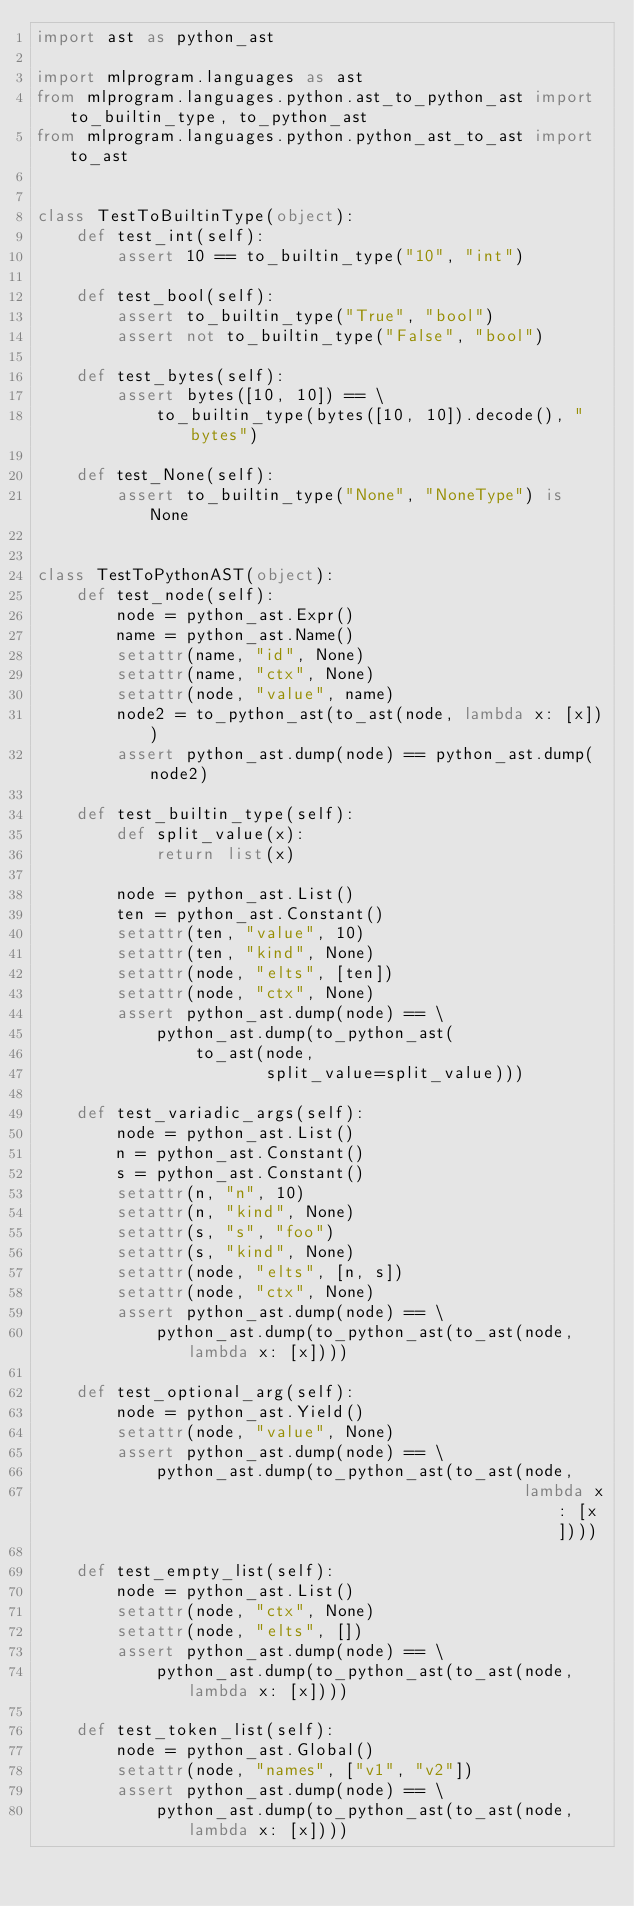Convert code to text. <code><loc_0><loc_0><loc_500><loc_500><_Python_>import ast as python_ast

import mlprogram.languages as ast
from mlprogram.languages.python.ast_to_python_ast import to_builtin_type, to_python_ast
from mlprogram.languages.python.python_ast_to_ast import to_ast


class TestToBuiltinType(object):
    def test_int(self):
        assert 10 == to_builtin_type("10", "int")

    def test_bool(self):
        assert to_builtin_type("True", "bool")
        assert not to_builtin_type("False", "bool")

    def test_bytes(self):
        assert bytes([10, 10]) == \
            to_builtin_type(bytes([10, 10]).decode(), "bytes")

    def test_None(self):
        assert to_builtin_type("None", "NoneType") is None


class TestToPythonAST(object):
    def test_node(self):
        node = python_ast.Expr()
        name = python_ast.Name()
        setattr(name, "id", None)
        setattr(name, "ctx", None)
        setattr(node, "value", name)
        node2 = to_python_ast(to_ast(node, lambda x: [x]))
        assert python_ast.dump(node) == python_ast.dump(node2)

    def test_builtin_type(self):
        def split_value(x):
            return list(x)

        node = python_ast.List()
        ten = python_ast.Constant()
        setattr(ten, "value", 10)
        setattr(ten, "kind", None)
        setattr(node, "elts", [ten])
        setattr(node, "ctx", None)
        assert python_ast.dump(node) == \
            python_ast.dump(to_python_ast(
                to_ast(node,
                       split_value=split_value)))

    def test_variadic_args(self):
        node = python_ast.List()
        n = python_ast.Constant()
        s = python_ast.Constant()
        setattr(n, "n", 10)
        setattr(n, "kind", None)
        setattr(s, "s", "foo")
        setattr(s, "kind", None)
        setattr(node, "elts", [n, s])
        setattr(node, "ctx", None)
        assert python_ast.dump(node) == \
            python_ast.dump(to_python_ast(to_ast(node, lambda x: [x])))

    def test_optional_arg(self):
        node = python_ast.Yield()
        setattr(node, "value", None)
        assert python_ast.dump(node) == \
            python_ast.dump(to_python_ast(to_ast(node,
                                                 lambda x: [x])))

    def test_empty_list(self):
        node = python_ast.List()
        setattr(node, "ctx", None)
        setattr(node, "elts", [])
        assert python_ast.dump(node) == \
            python_ast.dump(to_python_ast(to_ast(node, lambda x: [x])))

    def test_token_list(self):
        node = python_ast.Global()
        setattr(node, "names", ["v1", "v2"])
        assert python_ast.dump(node) == \
            python_ast.dump(to_python_ast(to_ast(node, lambda x: [x])))
</code> 